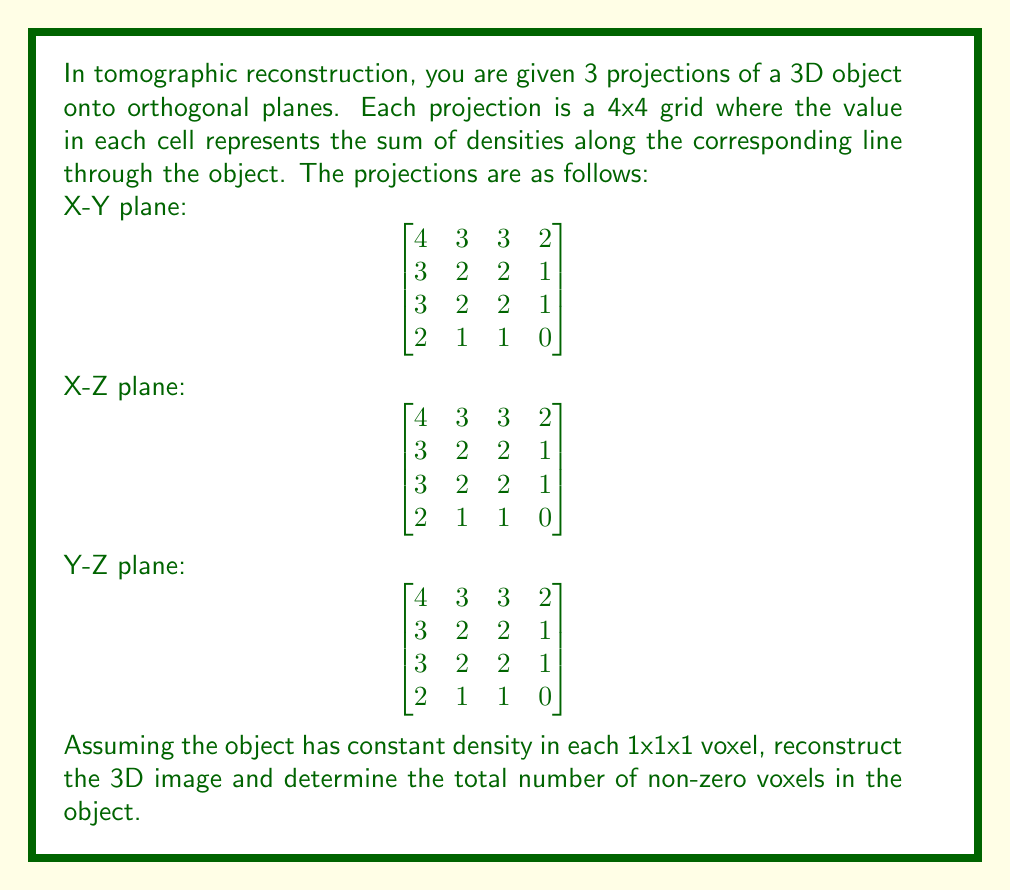Show me your answer to this math problem. To reconstruct the 3D image from the given projections, we'll follow these steps:

1) First, note that all three projections are identical, which suggests symmetry in the object.

2) Start with the corner voxel (0,0,0). Its value must be 2, as it's the only way to satisfy all three projections simultaneously for that corner.

3) Moving along any axis, the next voxel must be 1 to satisfy the projections. This applies to voxels (1,0,0), (0,1,0), and (0,0,1).

4) The voxel (1,1,1) must be 0, as the sum along any line passing through it is already satisfied by the previously determined voxels.

5) Due to the symmetry in the projections, we can conclude that the object is symmetrical, with the non-zero voxels forming an L-shape in each plane intersecting the origin.

6) The reconstructed 3D image can be represented as:

Layer z=0:
$$\begin{bmatrix}
2 & 1 & 1 & 0 \\
1 & 0 & 0 & 0 \\
1 & 0 & 0 & 0 \\
0 & 0 & 0 & 0
\end{bmatrix}$$

Layer z=1:
$$\begin{bmatrix}
1 & 0 & 0 & 0 \\
0 & 0 & 0 & 0 \\
0 & 0 & 0 & 0 \\
0 & 0 & 0 & 0
\end{bmatrix}$$

Layers z=2 and z=3 are all zeros.

7) Count the non-zero voxels: There are 5 non-zero voxels in layer z=0 and 1 non-zero voxel in layer z=1.

Therefore, the total number of non-zero voxels is 5 + 1 = 6.
Answer: 6 